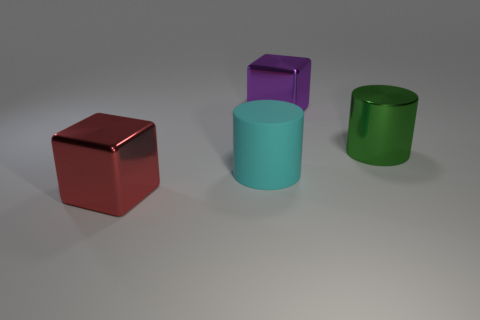Add 1 large shiny things. How many objects exist? 5 Add 4 tiny blocks. How many tiny blocks exist? 4 Subtract 0 brown spheres. How many objects are left? 4 Subtract all large balls. Subtract all purple cubes. How many objects are left? 3 Add 4 red things. How many red things are left? 5 